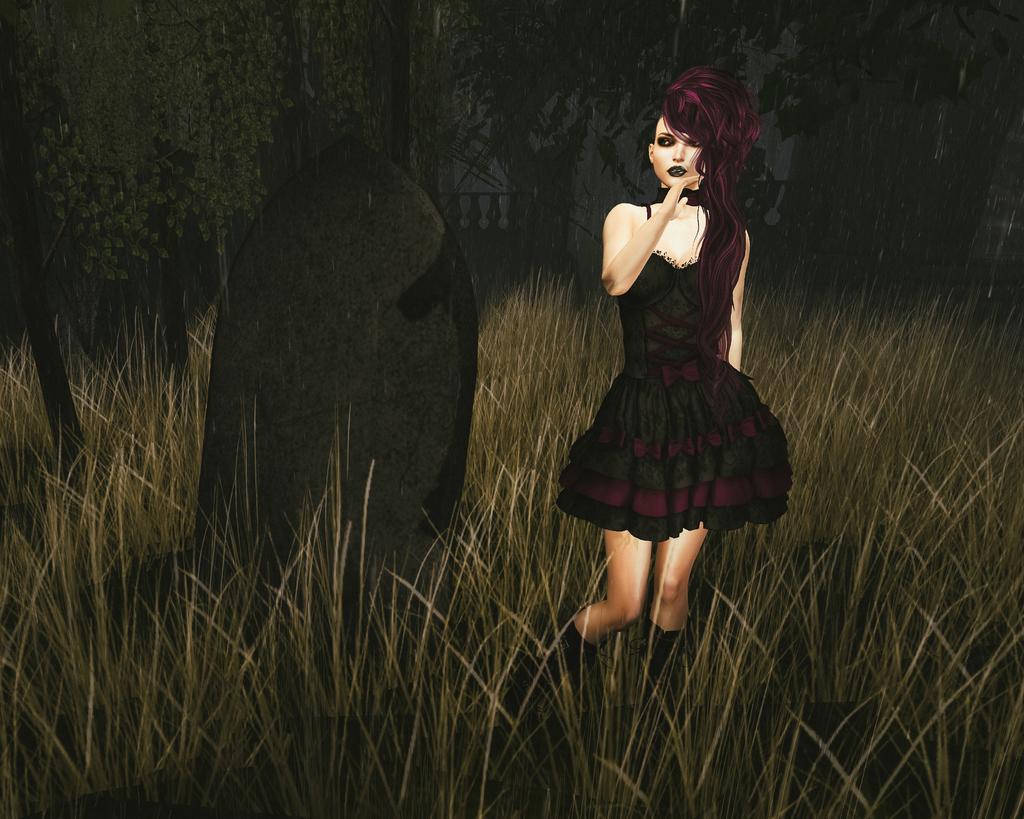How would you summarize this image in a sentence or two? This is an animated image we can see a woman is standing on the path and behind the woman there are trees and grass. 